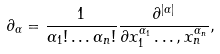<formula> <loc_0><loc_0><loc_500><loc_500>\partial _ { \alpha } = \frac { 1 } { \alpha _ { 1 } ! \dots \alpha _ { n } ! } \frac { \partial ^ { | \alpha | } } { \partial x _ { 1 } ^ { \alpha _ { 1 } } \dots , x _ { n } ^ { \alpha _ { n } } } ,</formula> 